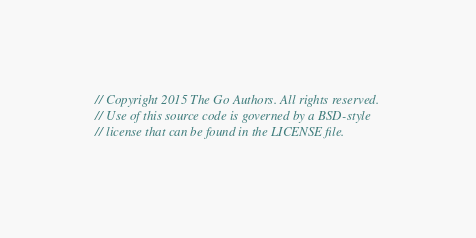Convert code to text. <code><loc_0><loc_0><loc_500><loc_500><_Go_>// Copyright 2015 The Go Authors. All rights reserved.
// Use of this source code is governed by a BSD-style
// license that can be found in the LICENSE file.
</code> 